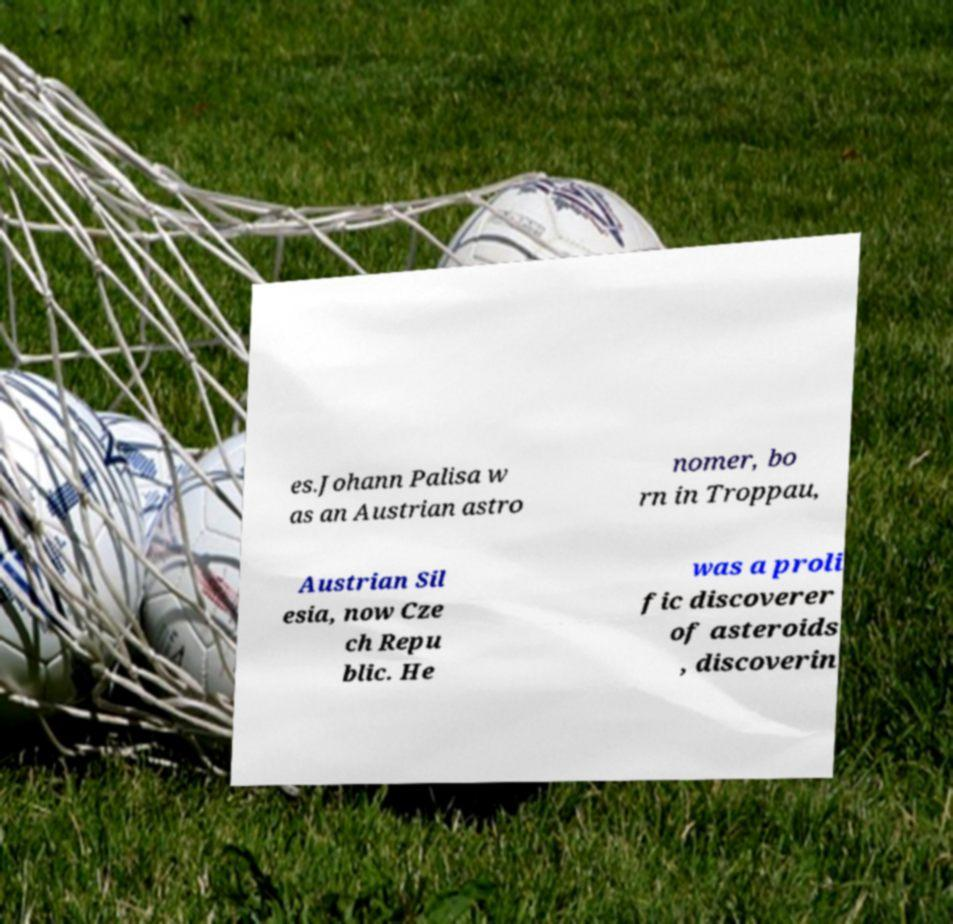Can you read and provide the text displayed in the image?This photo seems to have some interesting text. Can you extract and type it out for me? es.Johann Palisa w as an Austrian astro nomer, bo rn in Troppau, Austrian Sil esia, now Cze ch Repu blic. He was a proli fic discoverer of asteroids , discoverin 